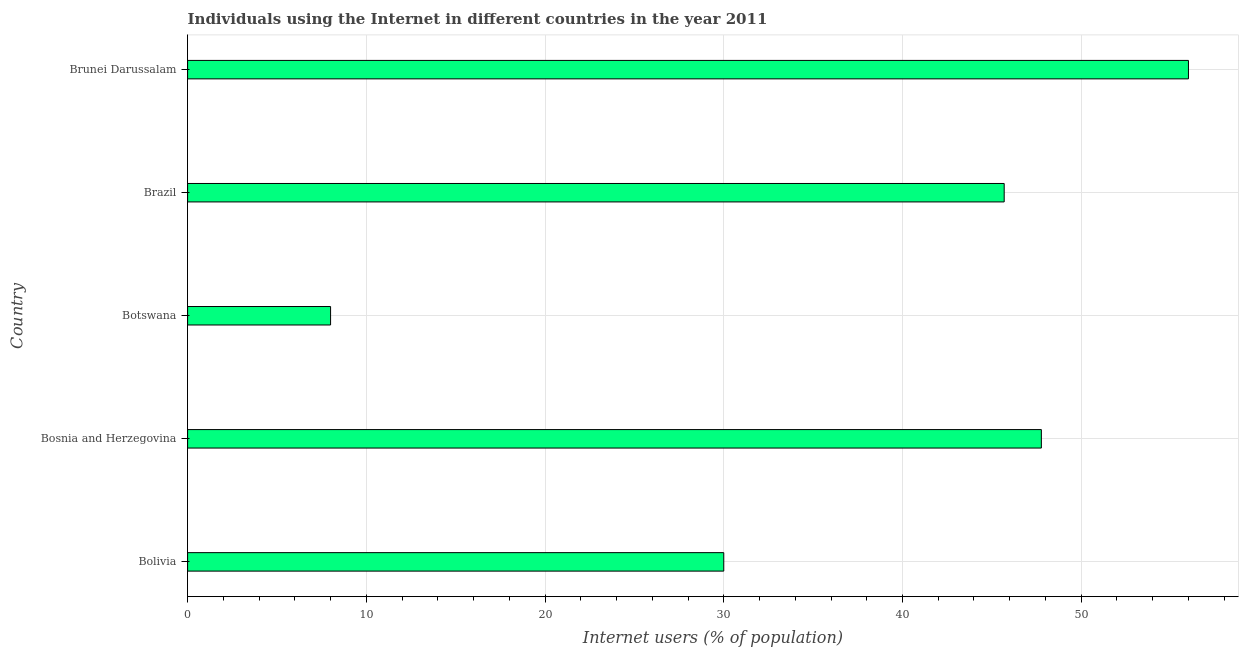Does the graph contain grids?
Offer a very short reply. Yes. What is the title of the graph?
Your answer should be compact. Individuals using the Internet in different countries in the year 2011. What is the label or title of the X-axis?
Your answer should be compact. Internet users (% of population). What is the label or title of the Y-axis?
Offer a very short reply. Country. Across all countries, what is the minimum number of internet users?
Offer a terse response. 8. In which country was the number of internet users maximum?
Give a very brief answer. Brunei Darussalam. In which country was the number of internet users minimum?
Offer a very short reply. Botswana. What is the sum of the number of internet users?
Your answer should be very brief. 187.46. What is the difference between the number of internet users in Bosnia and Herzegovina and Brunei Darussalam?
Provide a short and direct response. -8.23. What is the average number of internet users per country?
Keep it short and to the point. 37.49. What is the median number of internet users?
Your answer should be very brief. 45.69. What is the ratio of the number of internet users in Bolivia to that in Brunei Darussalam?
Give a very brief answer. 0.54. Is the difference between the number of internet users in Brazil and Brunei Darussalam greater than the difference between any two countries?
Provide a succinct answer. No. What is the difference between the highest and the second highest number of internet users?
Give a very brief answer. 8.23. Is the sum of the number of internet users in Bolivia and Brazil greater than the maximum number of internet users across all countries?
Offer a very short reply. Yes. What is the difference between the highest and the lowest number of internet users?
Your answer should be compact. 48. In how many countries, is the number of internet users greater than the average number of internet users taken over all countries?
Provide a short and direct response. 3. How many bars are there?
Provide a short and direct response. 5. How many countries are there in the graph?
Provide a short and direct response. 5. What is the difference between two consecutive major ticks on the X-axis?
Keep it short and to the point. 10. What is the Internet users (% of population) in Bosnia and Herzegovina?
Ensure brevity in your answer.  47.77. What is the Internet users (% of population) in Botswana?
Provide a succinct answer. 8. What is the Internet users (% of population) of Brazil?
Offer a terse response. 45.69. What is the difference between the Internet users (% of population) in Bolivia and Bosnia and Herzegovina?
Your answer should be compact. -17.77. What is the difference between the Internet users (% of population) in Bolivia and Brazil?
Offer a terse response. -15.69. What is the difference between the Internet users (% of population) in Bolivia and Brunei Darussalam?
Offer a terse response. -26. What is the difference between the Internet users (% of population) in Bosnia and Herzegovina and Botswana?
Keep it short and to the point. 39.77. What is the difference between the Internet users (% of population) in Bosnia and Herzegovina and Brazil?
Offer a terse response. 2.08. What is the difference between the Internet users (% of population) in Bosnia and Herzegovina and Brunei Darussalam?
Your answer should be compact. -8.23. What is the difference between the Internet users (% of population) in Botswana and Brazil?
Give a very brief answer. -37.69. What is the difference between the Internet users (% of population) in Botswana and Brunei Darussalam?
Provide a short and direct response. -48. What is the difference between the Internet users (% of population) in Brazil and Brunei Darussalam?
Offer a very short reply. -10.31. What is the ratio of the Internet users (% of population) in Bolivia to that in Bosnia and Herzegovina?
Keep it short and to the point. 0.63. What is the ratio of the Internet users (% of population) in Bolivia to that in Botswana?
Offer a terse response. 3.75. What is the ratio of the Internet users (% of population) in Bolivia to that in Brazil?
Offer a terse response. 0.66. What is the ratio of the Internet users (% of population) in Bolivia to that in Brunei Darussalam?
Your answer should be very brief. 0.54. What is the ratio of the Internet users (% of population) in Bosnia and Herzegovina to that in Botswana?
Provide a short and direct response. 5.97. What is the ratio of the Internet users (% of population) in Bosnia and Herzegovina to that in Brazil?
Make the answer very short. 1.05. What is the ratio of the Internet users (% of population) in Bosnia and Herzegovina to that in Brunei Darussalam?
Give a very brief answer. 0.85. What is the ratio of the Internet users (% of population) in Botswana to that in Brazil?
Ensure brevity in your answer.  0.17. What is the ratio of the Internet users (% of population) in Botswana to that in Brunei Darussalam?
Keep it short and to the point. 0.14. What is the ratio of the Internet users (% of population) in Brazil to that in Brunei Darussalam?
Keep it short and to the point. 0.82. 